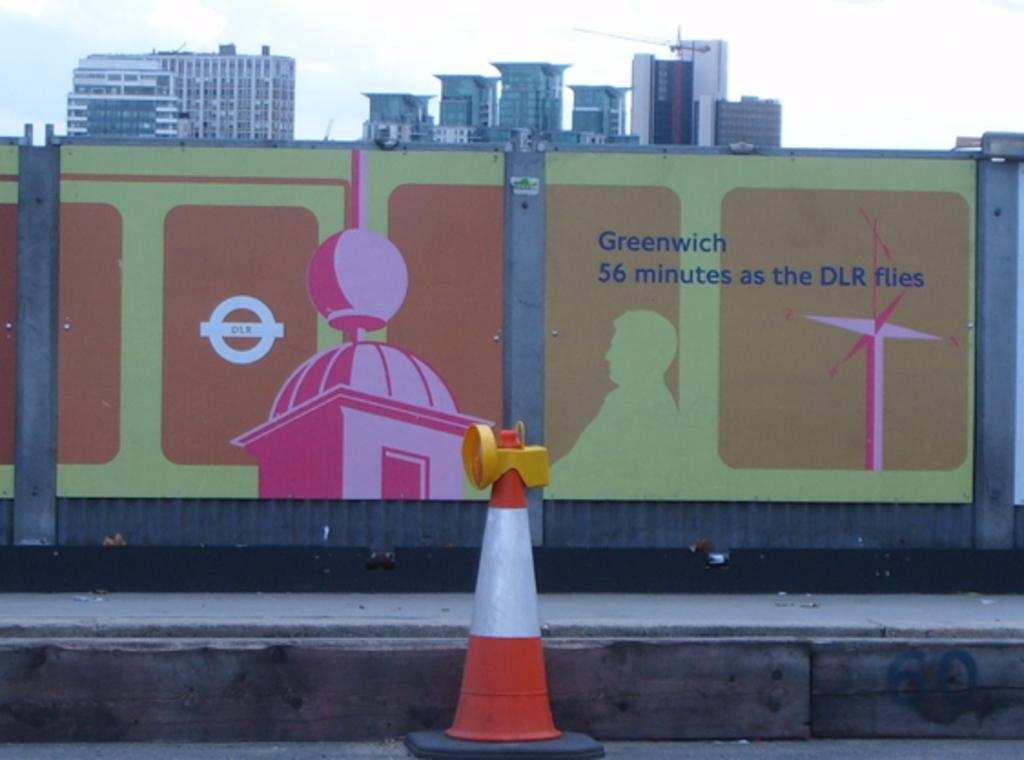Provide a one-sentence caption for the provided image. the mural on the wall says that Greenwish is 56 minutes as the DLR flies. 